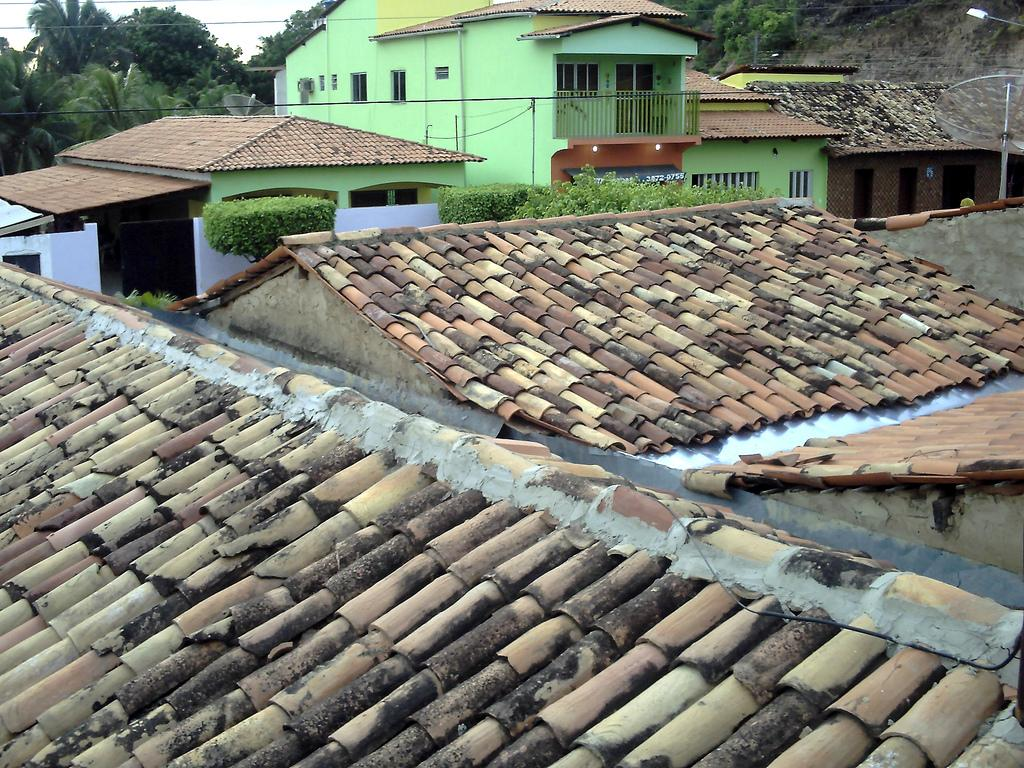What type of structures can be seen in the image? There are buildings in the image. What part of a building is visible in the image? There is a roof visible in the image. What architectural feature is present in the image? There is a railing to a building in the image. What source of illumination is present in the image? There is a light in the image. What type of vegetation is present in the image? There are trees in the image. What can be seen in the background of the image? The sky is visible in the background of the image. Reasoning: Let'ing: Let's think step by step in order to produce the conversation. We start by identifying the main subjects and objects in the image based on the provided facts. We then formulate questions that focus on the location and characteristics of these subjects and objects, ensuring that each question can be answered definitively with the information given. We avoid yes/no questions and ensure that the language is simple and clear. Absurd Question/Answer: Where are the flowers located in the image? There are no flowers present in the image. What type of boot is being worn by the person in the image? There is no person or boot present in the image. 